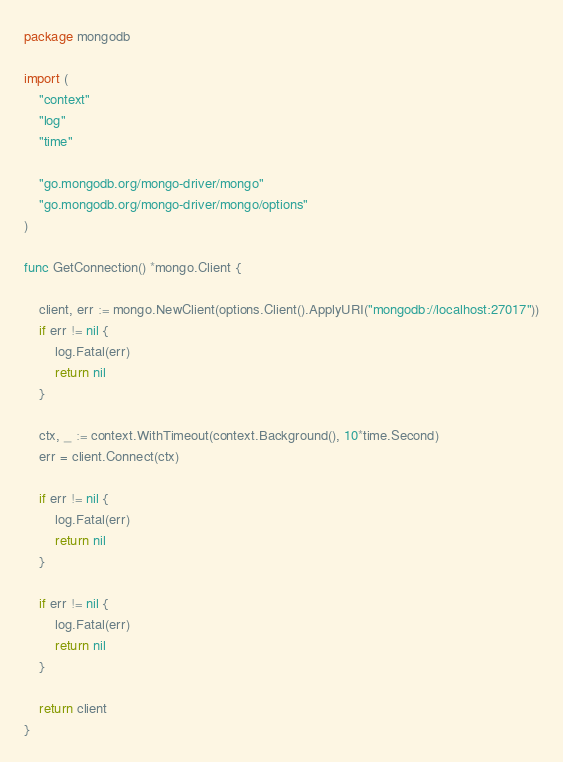Convert code to text. <code><loc_0><loc_0><loc_500><loc_500><_Go_>package mongodb

import (
	"context"
	"log"
	"time"

	"go.mongodb.org/mongo-driver/mongo"
	"go.mongodb.org/mongo-driver/mongo/options"
)

func GetConnection() *mongo.Client {

	client, err := mongo.NewClient(options.Client().ApplyURI("mongodb://localhost:27017"))
	if err != nil {
		log.Fatal(err)
		return nil
	}

	ctx, _ := context.WithTimeout(context.Background(), 10*time.Second)
	err = client.Connect(ctx)

	if err != nil {
		log.Fatal(err)
		return nil
	}

	if err != nil {
		log.Fatal(err)
		return nil
	}

	return client
}
</code> 